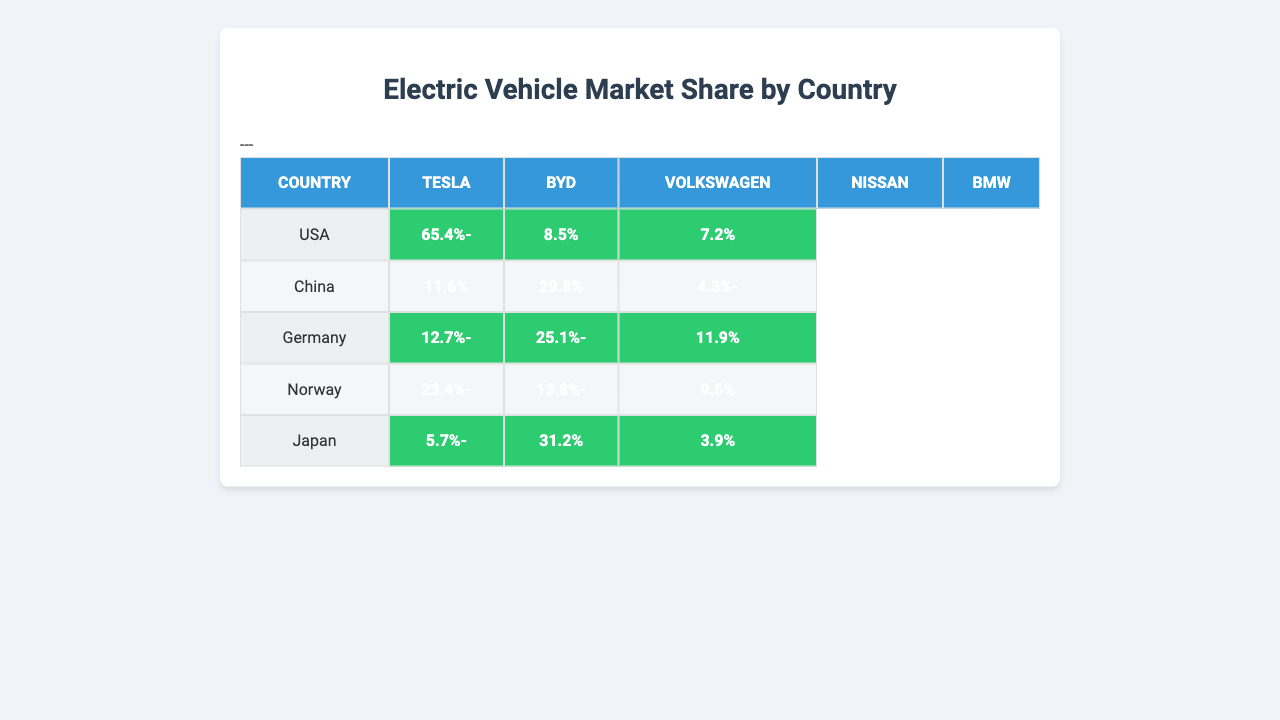What is the market share of Tesla in the USA? The table shows that Tesla has a market share of 65.4% in the USA.
Answer: 65.4% Which manufacturer has the highest market share in China? According to the table, BYD has the highest market share in China at 29.8%.
Answer: BYD Is Nissan present in Germany's market share? Yes, the table lists Nissan under Germany's market share, showing it has 11.9%.
Answer: Yes What is the total market share of Volkswagen across all countries? The market share for Volkswagen is 4.3% in China, 25.1% in Germany, and 13.8% in Norway. Adding these values gives 4.3 + 25.1 + 13.8 = 43.2%.
Answer: 43.2% Which country has the lowest market share for Tesla? The table indicates that Japan has Tesla’s lowest market share at 5.7%.
Answer: Japan How much higher is Tesla’s market share in the USA compared to Japan? Tesla has a market share of 65.4% in the USA, and 5.7% in Japan. The difference is 65.4 - 5.7 = 59.7%.
Answer: 59.7% Which country has the highest overall market for electric vehicles among those listed? By looking at the highest individual shares, the USA has Tesla with the largest market share of 65.4%, indicating the highest market overall among the countries.
Answer: USA What is the average market share for BMW across the five countries? For BMW: USA (7.2%), Germany (11.9%), Norway (9.5%), and Japan (3.9%). The total is 7.2 + 11.9 + 9.5 + 3.9 = 32.5%. Dividing by 4 gives the average of 32.5/4 = 8.125%.
Answer: 8.125% Is Tesla the only manufacturer present in Japan’s electric vehicle market share? No, the table shows that Nissan and BMW are also included in Japan's market share along with Tesla.
Answer: No What percentage more market share does Tesla have in Norway compared to BMW? Tesla has 23.4% in Norway and BMW has 9.5%. The difference is 23.4 - 9.5 = 13.9%.
Answer: 13.9% 